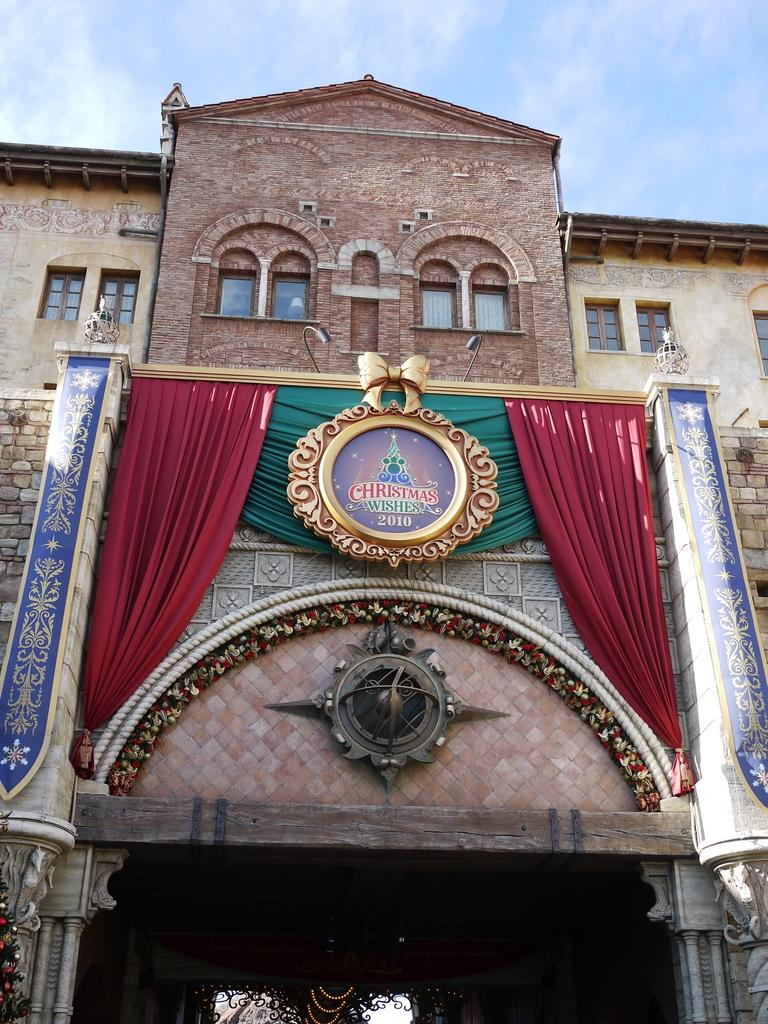What type of structure is visible in the image? There is a building with windows in the image. How would you describe the weather based on the image? The sky is cloudy in the image. Are there any window treatments visible in the image? Yes, there are curtains visible in the image. What object can be seen in the image that might be used for displaying information or announcements? There is a board present in the image. How much does the dog cost in the image? There is no dog present in the image, so it is not possible to determine its cost. 